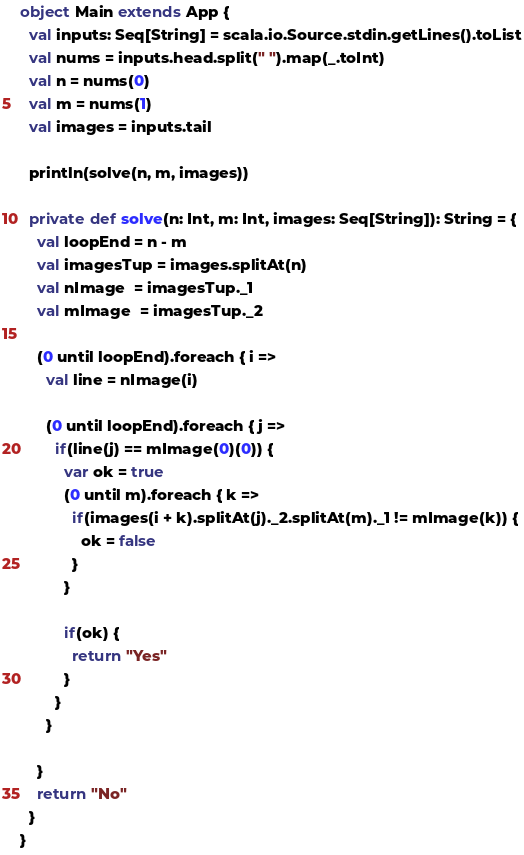Convert code to text. <code><loc_0><loc_0><loc_500><loc_500><_Scala_>object Main extends App {
  val inputs: Seq[String] = scala.io.Source.stdin.getLines().toList
  val nums = inputs.head.split(" ").map(_.toInt)
  val n = nums(0)
  val m = nums(1)
  val images = inputs.tail

  println(solve(n, m, images))

  private def solve(n: Int, m: Int, images: Seq[String]): String = {
    val loopEnd = n - m
    val imagesTup = images.splitAt(n)
    val nImage  = imagesTup._1
    val mImage  = imagesTup._2

    (0 until loopEnd).foreach { i =>
      val line = nImage(i)

      (0 until loopEnd).foreach { j =>
        if(line(j) == mImage(0)(0)) {
          var ok = true
          (0 until m).foreach { k =>
            if(images(i + k).splitAt(j)._2.splitAt(m)._1 != mImage(k)) {
              ok = false
            }
          }

          if(ok) {
            return "Yes"
          }
        }
      }

    }
    return "No"
  }
}</code> 